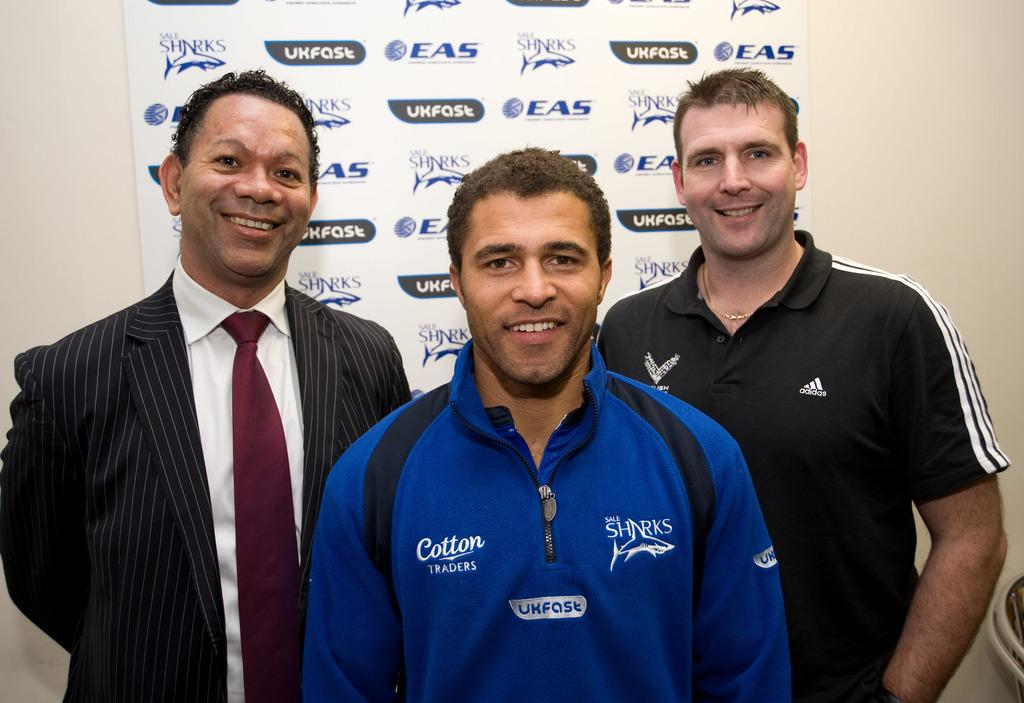<image>
Summarize the visual content of the image. 3 men smiling for a picture, the Sale Sharks logo is displayed in the back and on a man's shirt 